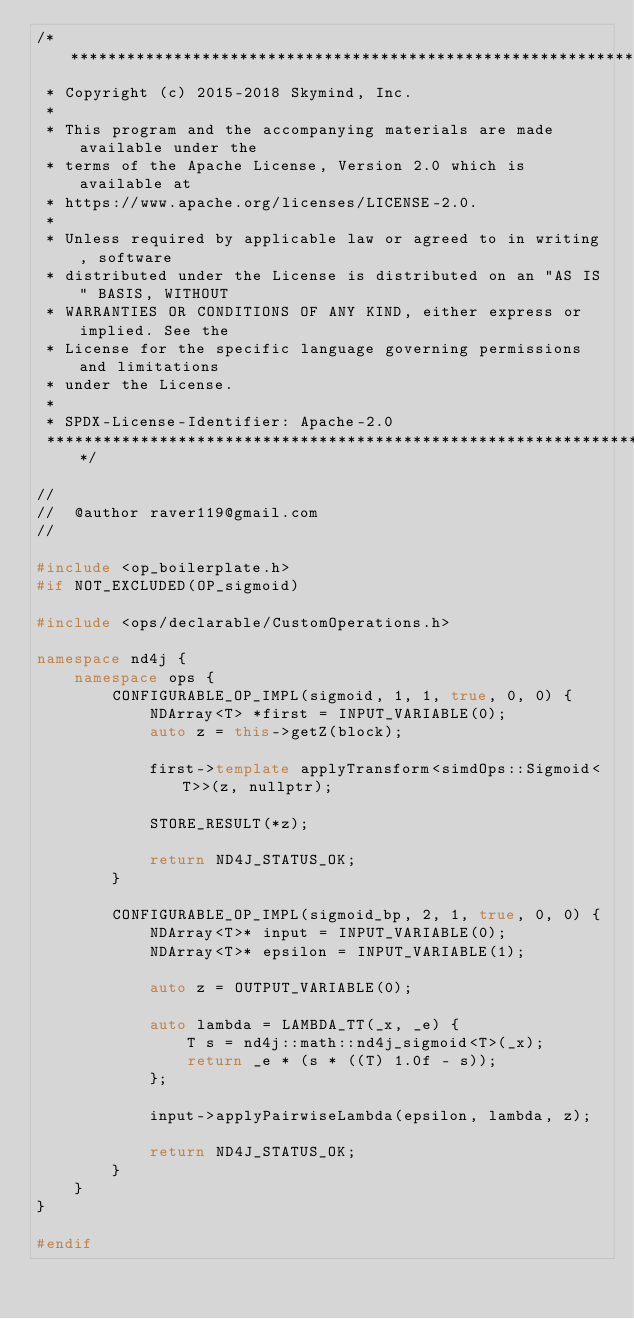<code> <loc_0><loc_0><loc_500><loc_500><_C++_>/*******************************************************************************
 * Copyright (c) 2015-2018 Skymind, Inc.
 *
 * This program and the accompanying materials are made available under the
 * terms of the Apache License, Version 2.0 which is available at
 * https://www.apache.org/licenses/LICENSE-2.0.
 *
 * Unless required by applicable law or agreed to in writing, software
 * distributed under the License is distributed on an "AS IS" BASIS, WITHOUT
 * WARRANTIES OR CONDITIONS OF ANY KIND, either express or implied. See the
 * License for the specific language governing permissions and limitations
 * under the License.
 *
 * SPDX-License-Identifier: Apache-2.0
 ******************************************************************************/

//
//  @author raver119@gmail.com
//

#include <op_boilerplate.h>
#if NOT_EXCLUDED(OP_sigmoid)

#include <ops/declarable/CustomOperations.h>

namespace nd4j {
    namespace ops {
        CONFIGURABLE_OP_IMPL(sigmoid, 1, 1, true, 0, 0) {
            NDArray<T> *first = INPUT_VARIABLE(0);
            auto z = this->getZ(block);

            first->template applyTransform<simdOps::Sigmoid<T>>(z, nullptr);

            STORE_RESULT(*z);

            return ND4J_STATUS_OK;
        }

        CONFIGURABLE_OP_IMPL(sigmoid_bp, 2, 1, true, 0, 0) {
            NDArray<T>* input = INPUT_VARIABLE(0);
            NDArray<T>* epsilon = INPUT_VARIABLE(1);

            auto z = OUTPUT_VARIABLE(0);

            auto lambda = LAMBDA_TT(_x, _e) {
                T s = nd4j::math::nd4j_sigmoid<T>(_x);
                return _e * (s * ((T) 1.0f - s));
            };

            input->applyPairwiseLambda(epsilon, lambda, z);  

            return ND4J_STATUS_OK;
        }
    }
}

#endif</code> 